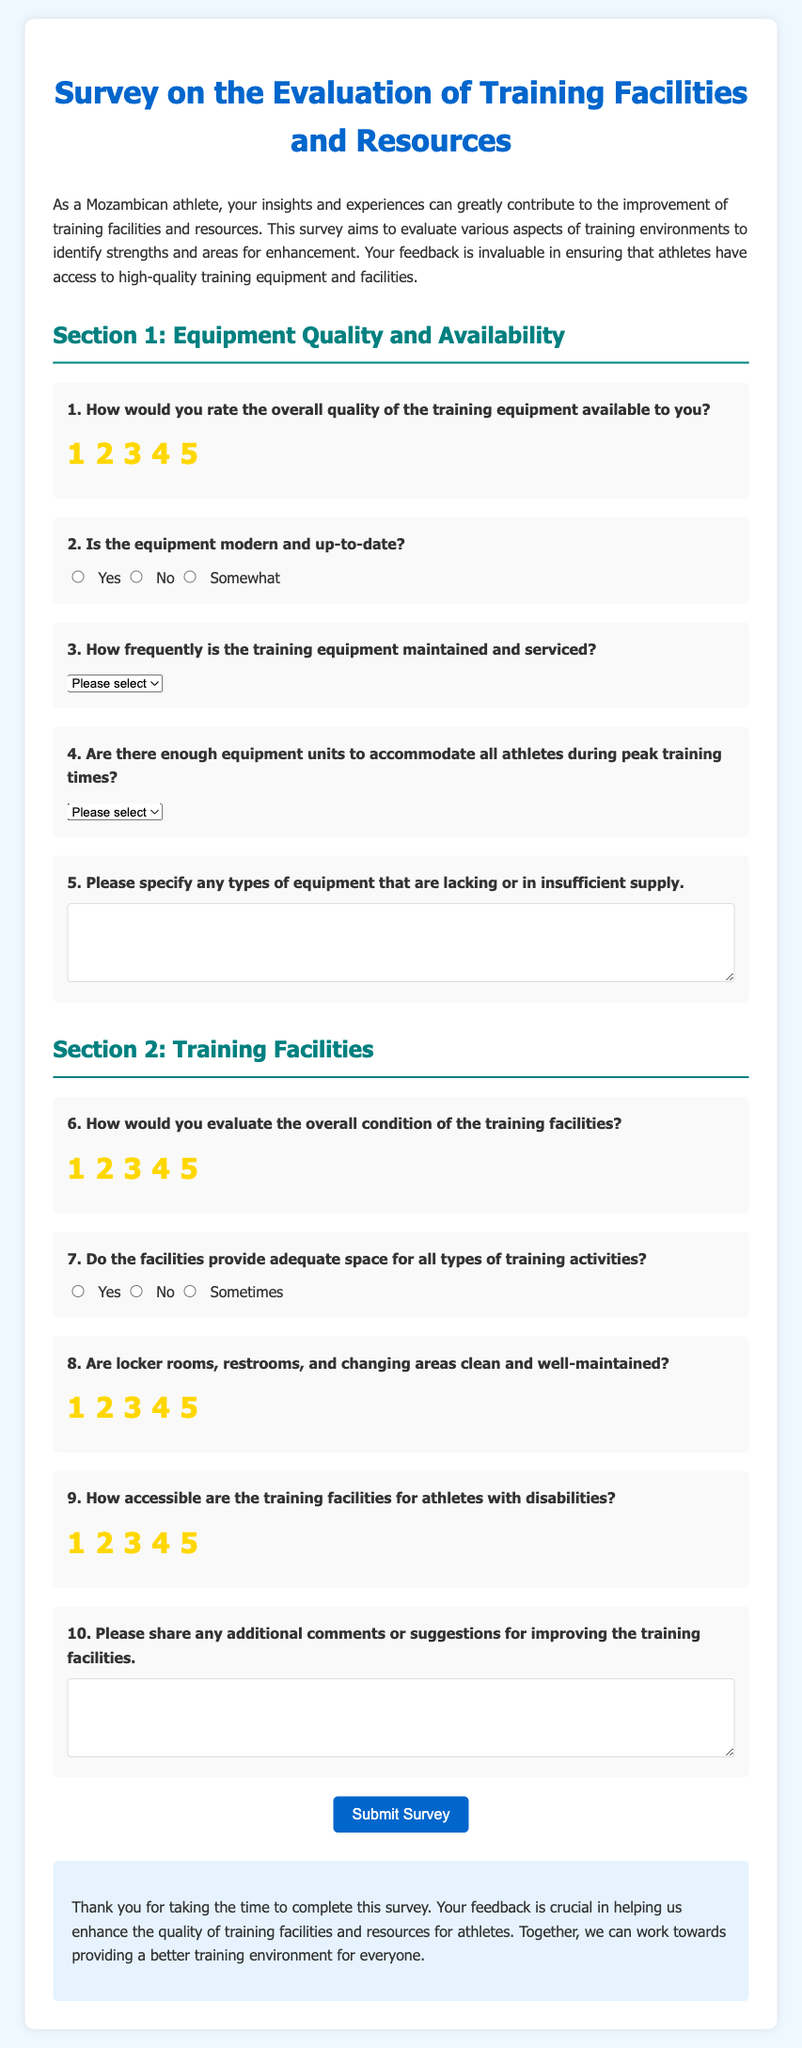What is the title of the survey? The title of the survey is specified in the document's `<title>` tag and the header at the top of the page.
Answer: Survey on the Evaluation of Training Facilities and Resources How many sections are in the survey? The survey contains two sections as indicated in the document.
Answer: Two What is the maximum rating for the quality of training equipment? The maximum rating is specified by the rating scale in Section 1.
Answer: 5 What is the asked frequency for maintenance of the training equipment? The frequency options provided in the document indicate how often equipment should be maintained.
Answer: Weekly, Monthly, Quarterly, Annually, Never What is the question number for the equipment availability inquiry? The question number can be identified by the label before the question about equipment availability.
Answer: 4 What type of comment is solicited in the last question? The final question invites participants to share their thoughts on enhancing training facilities.
Answer: Additional comments or suggestions What is the evaluation method used for training facility condition? The evaluation method is presented using a rating system in the document.
Answer: Rating scale How are the locker rooms described in the survey? The survey asks about the cleanliness and maintenance of locker rooms in a specific question.
Answer: Clean and well-maintained What is the intended purpose of the survey? The survey's purpose is detailed in the introduction, focusing on athlete feedback.
Answer: To evaluate training facilities and resources Does the survey contain an option for suggestions? Suggestions are specifically requested in one of the questions of the survey.
Answer: Yes 